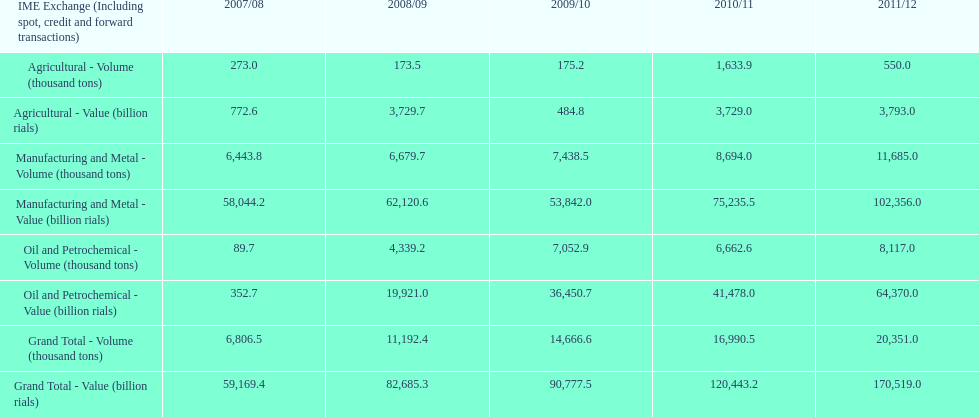In how many years was the value of agriculture, in billion rials, greater than 500 in iran? 4. 